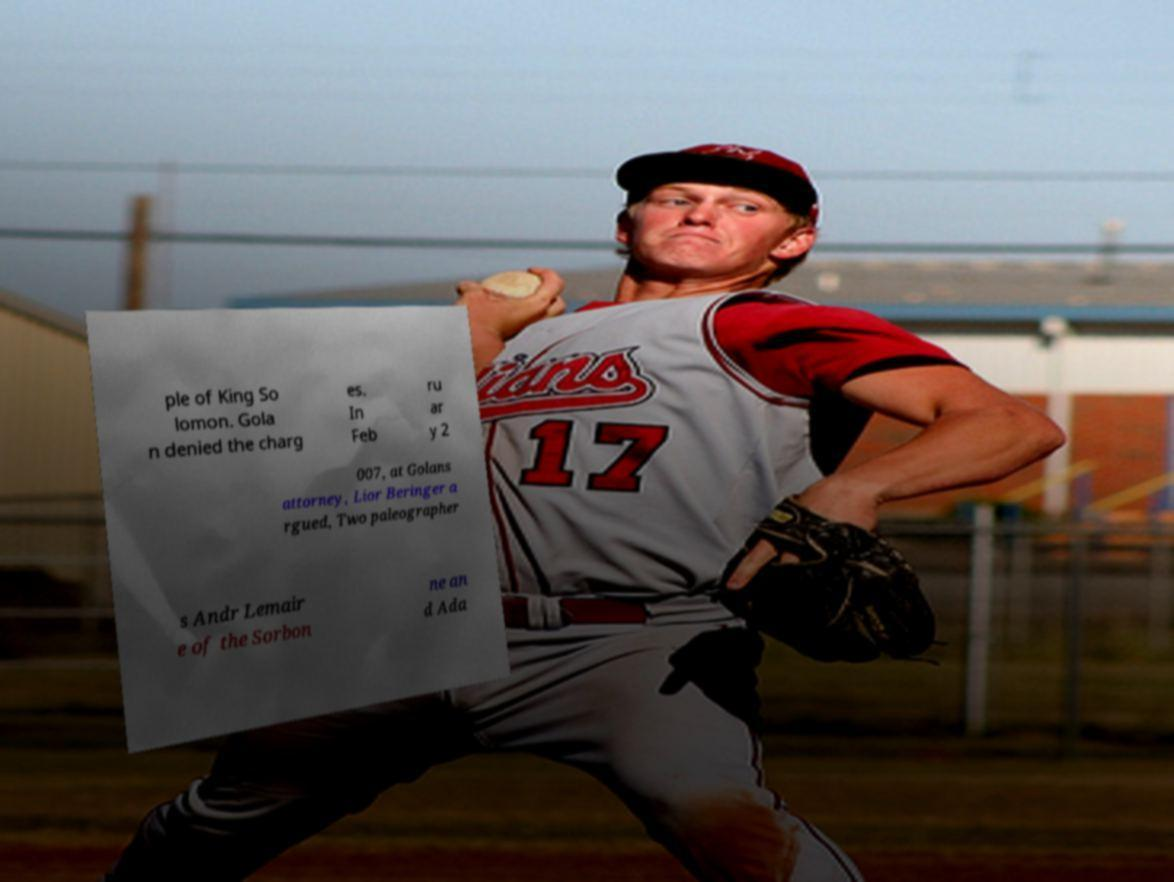Can you accurately transcribe the text from the provided image for me? ple of King So lomon. Gola n denied the charg es. In Feb ru ar y 2 007, at Golans attorney, Lior Beringer a rgued, Two paleographer s Andr Lemair e of the Sorbon ne an d Ada 